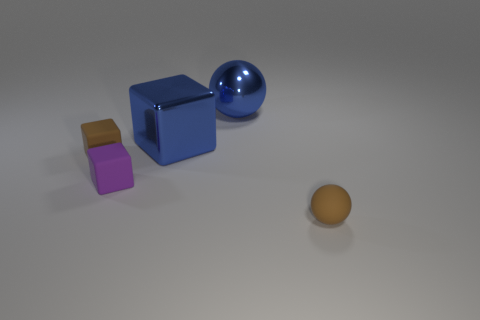What is the material of the small purple cube?
Ensure brevity in your answer.  Rubber. There is a sphere behind the purple thing; is it the same size as the large blue shiny block?
Give a very brief answer. Yes. What number of objects are either shiny balls or tiny purple rubber blocks?
Ensure brevity in your answer.  2. There is a thing that is the same color as the rubber ball; what is its shape?
Provide a short and direct response. Cube. How big is the thing that is both behind the tiny brown rubber block and on the left side of the large blue ball?
Give a very brief answer. Large. How many large shiny spheres are there?
Give a very brief answer. 1. What number of cylinders are either matte objects or yellow matte things?
Your answer should be very brief. 0. How many small purple blocks are left of the brown object that is behind the rubber sphere in front of the small purple matte block?
Your answer should be compact. 0. There is another rubber cube that is the same size as the purple cube; what is its color?
Ensure brevity in your answer.  Brown. How many other things are there of the same color as the shiny block?
Your answer should be compact. 1. 